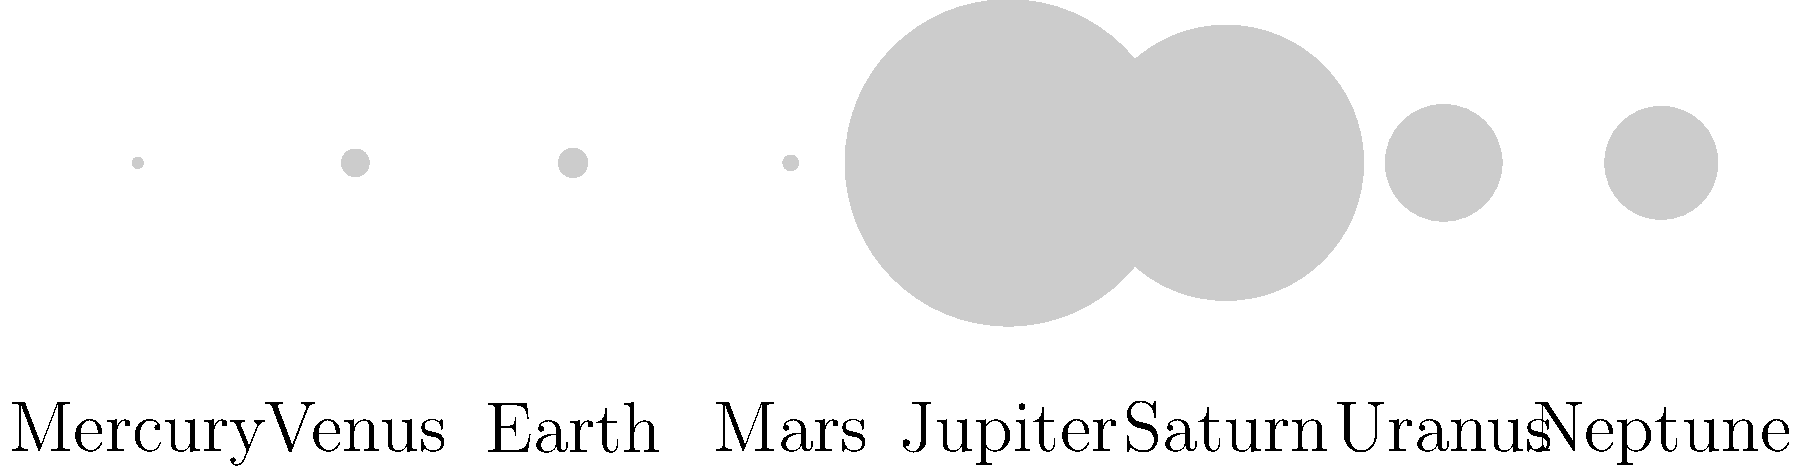As a brand representative exploring alternative marketing methods, you're considering using astronomical facts in your campaigns. Which planet in our solar system would provide the most surface area for hypothetical advertising, and how does this relate to consumer reach in marketing? To answer this question, let's analyze the relative sizes of the planets in our solar system:

1. Jupiter is the largest planet, with a diameter of 142,984 km.
2. Saturn is the second-largest, with a diameter of 120,536 km.
3. The next largest planets are Uranus and Neptune, with diameters of 51,118 km and 49,528 km, respectively.
4. Earth, our home planet, has a diameter of 12,756 km.

To calculate the surface area, we use the formula for the surface area of a sphere: $A = 4\pi r^2$, where $r$ is the radius (half the diameter).

For Jupiter:
$r = 142,984 / 2 = 71,492$ km
$A = 4\pi (71,492)^2 \approx 6.41 \times 10^{10}$ km²

For comparison, Earth's surface area is:
$r = 12,756 / 2 = 6,378$ km
$A = 4\pi (6,378)^2 \approx 5.10 \times 10^8$ km²

Jupiter's surface area is about 125 times larger than Earth's.

In terms of marketing, this relates to consumer reach in several ways:
1. Larger surface area symbolizes greater potential audience reach.
2. Jupiter's size could represent the idea of "thinking big" in marketing campaigns.
3. The vast difference between Jupiter and other planets could be used to illustrate market dominance or growth potential.

While we can't actually advertise on Jupiter, its immense size serves as a powerful metaphor for broad market reach and impactful marketing strategies.
Answer: Jupiter, with 125 times Earth's surface area, symbolizing maximum reach and impact in marketing. 